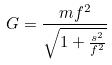<formula> <loc_0><loc_0><loc_500><loc_500>G = \frac { m f ^ { 2 } } { \sqrt { 1 + \frac { s ^ { 2 } } { f ^ { 2 } } } }</formula> 